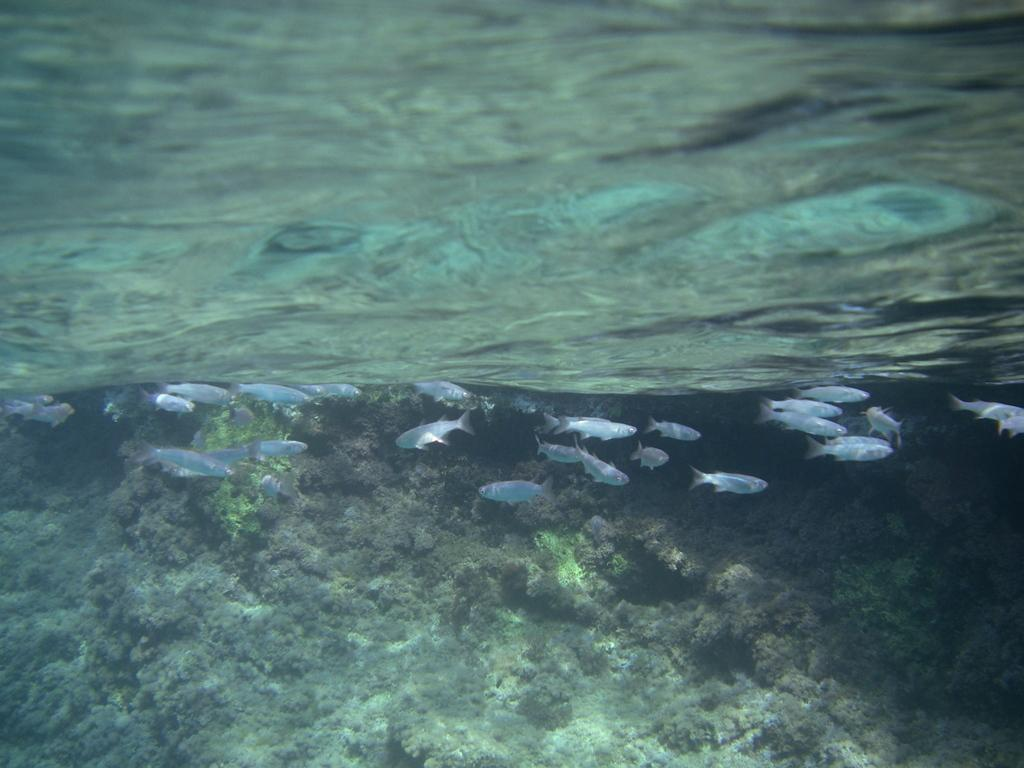What is the primary element in the image? There is water in the image. What can be seen swimming in the water? There are fishes in the water. What is visible below the water's surface? The ground is visible in the image. What type of vegetation is present in the water? There are water plants in the image. What type of record can be seen spinning on the water's surface in the image? There is no record present in the image; it features water with fishes, water plants, and a visible ground. 